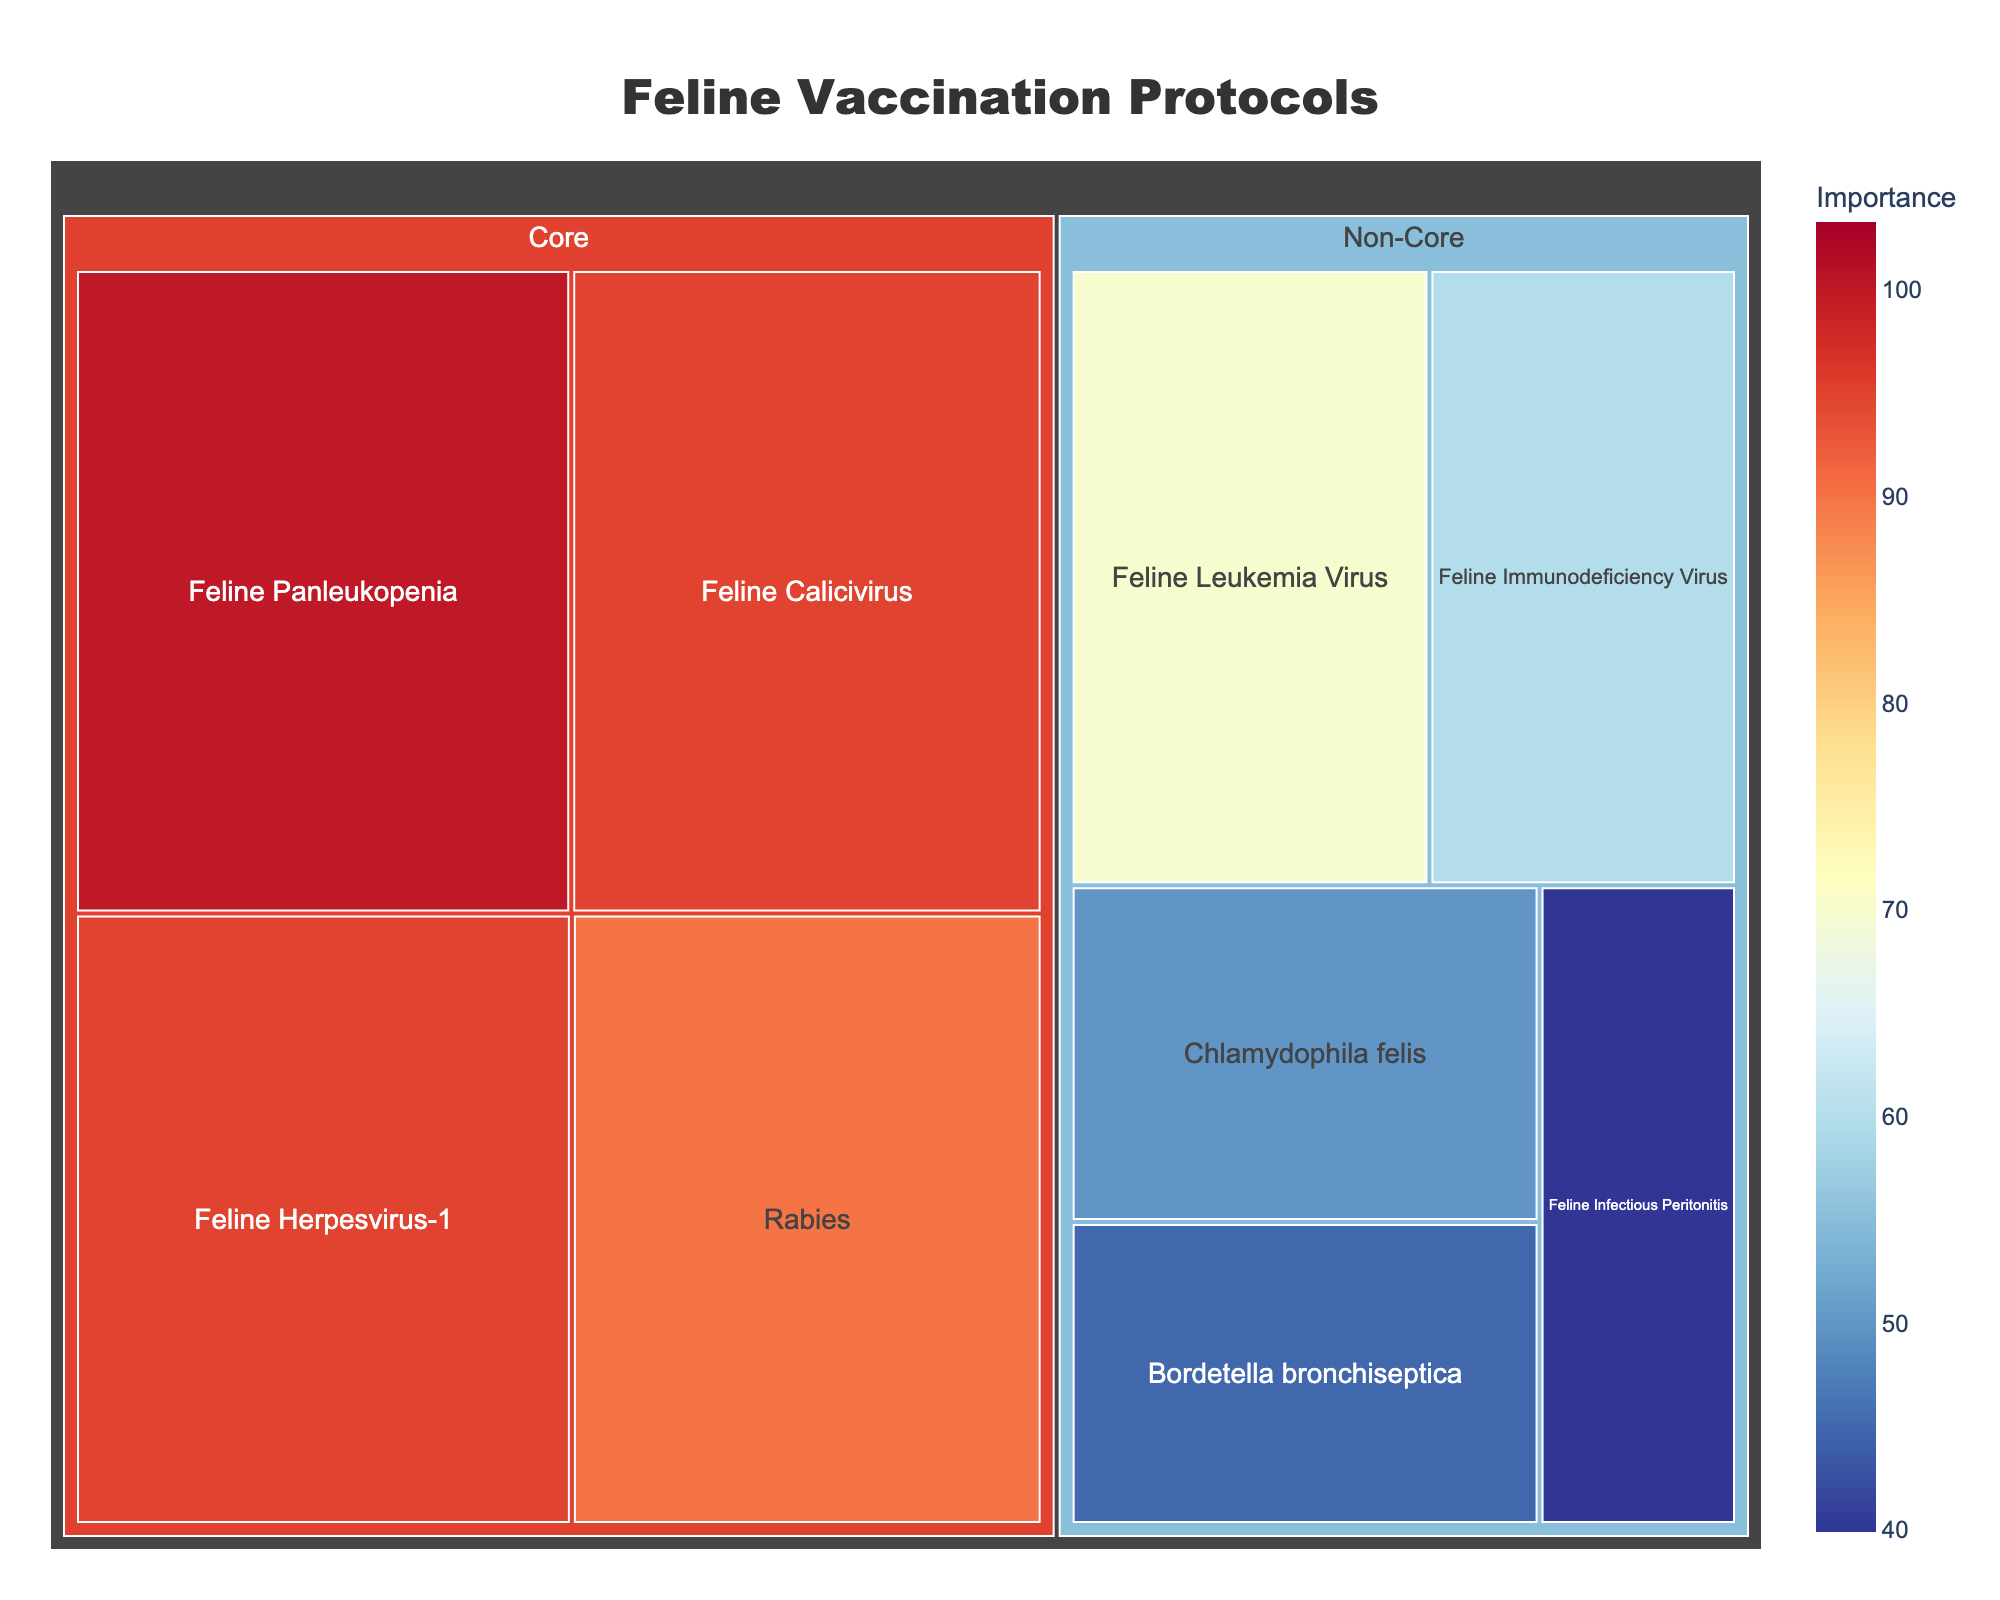Which vaccine has the highest importance score? The treemap shows the importance score for each vaccine. The Feline Panleukopenia vaccine under the Core category has the highest importance score of 100.
Answer: Feline Panleukopenia How often is the Feline Leukemia Virus vaccine administered? By hovering over or checking the section of the treemap representing Feline Leukemia Virus under Non-Core Vaccines, the hover data shows an annual frequency.
Answer: Annual What is the average importance score of core vaccines? Core vaccines include Feline Panleukopenia (100), Feline Herpesvirus-1 (95), Feline Calicivirus (95), and Rabies (90). The average is calculated as (100 + 95 + 95 + 90) / 4 = 95.
Answer: 95 Which is more frequently administered: Rabies or Feline Immunodeficiency Virus? Rabies vaccine is either annual or triennial, while Feline Immunodeficiency Virus is biennial. Annual is more frequent compared to biennial so Rabies is administered more often.
Answer: Rabies What is the combined importance score of non-core vaccines with an annual frequency? Non-core vaccines with an annual frequency are Feline Leukemia Virus (70), Chlamydophila felis (50), and Bordetella bronchiseptica (45). Their combined score is 70 + 50 + 45 = 165.
Answer: 165 Which category has a greater total importance score: Core or Non-Core? Calculate the total importance scores by summing the scores of each category. Core: 100 + 95 + 95 + 90 = 380. Non-Core: 70 + 60 + 50 + 45 + 40 = 265. Core has a greater total importance score.
Answer: Core Is the importance of Rabies vaccine higher or lower than Feline Calicivirus? The importance score of Rabies is 90, whereas Feline Calicivirus is 95. Rabies has a lower importance score than Feline Calicivirus.
Answer: Lower How many vaccines are administered annually? The vaccines administered annually include Feline Panleukopenia, Feline Herpesvirus-1, Feline Calicivirus, Rabies (for annual frequency), Feline Leukemia Virus, Chlamydophila felis, and Bordetella bronchiseptica. Count: 7.
Answer: 7 Which vaccines are categorized under Core Vaccines? By examining the treemap, the Core Vaccines category includes Feline Panleukopenia, Feline Herpesvirus-1, Feline Calicivirus, and Rabies.
Answer: Feline Panleukopenia, Feline Herpesvirus-1, Feline Calicivirus, Rabies What is the importance score range for non-core vaccines? The importance scores of non-core vaccines range from the lowest score of 40 (Feline Infectious Peritonitis) to the highest score of 70 (Feline Leukemia Virus).
Answer: 40 to 70 